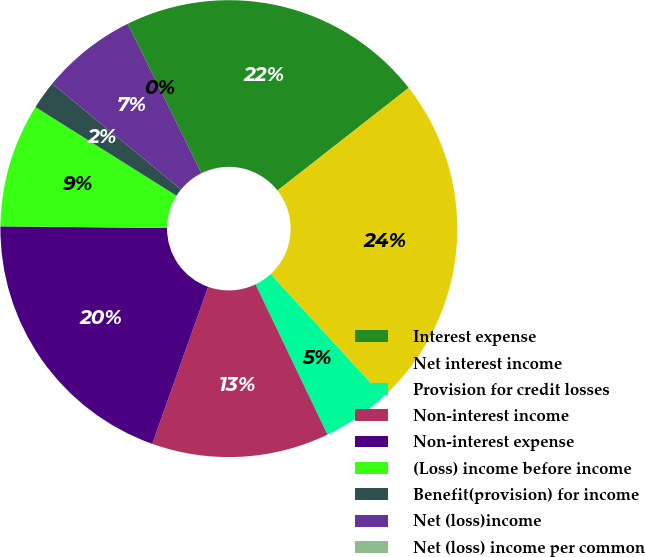Convert chart to OTSL. <chart><loc_0><loc_0><loc_500><loc_500><pie_chart><fcel>Interest expense<fcel>Net interest income<fcel>Provision for credit losses<fcel>Non-interest income<fcel>Non-interest expense<fcel>(Loss) income before income<fcel>Benefit(provision) for income<fcel>Net (loss)income<fcel>Net (loss) income per common<nl><fcel>21.73%<fcel>23.74%<fcel>4.72%<fcel>12.55%<fcel>19.72%<fcel>8.77%<fcel>2.01%<fcel>6.76%<fcel>0.0%<nl></chart> 